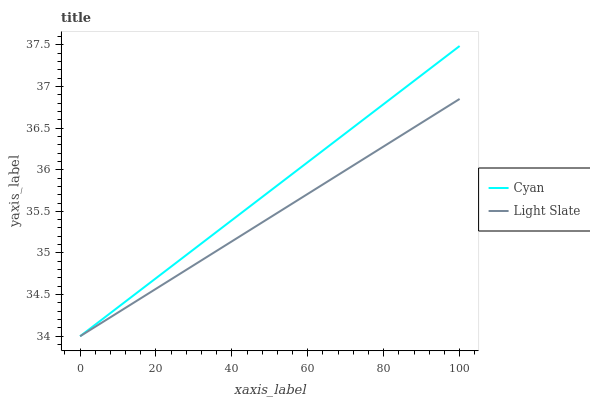Does Light Slate have the minimum area under the curve?
Answer yes or no. Yes. Does Cyan have the maximum area under the curve?
Answer yes or no. Yes. Does Cyan have the minimum area under the curve?
Answer yes or no. No. Is Cyan the smoothest?
Answer yes or no. Yes. Is Light Slate the roughest?
Answer yes or no. Yes. Is Cyan the roughest?
Answer yes or no. No. Does Cyan have the highest value?
Answer yes or no. Yes. 